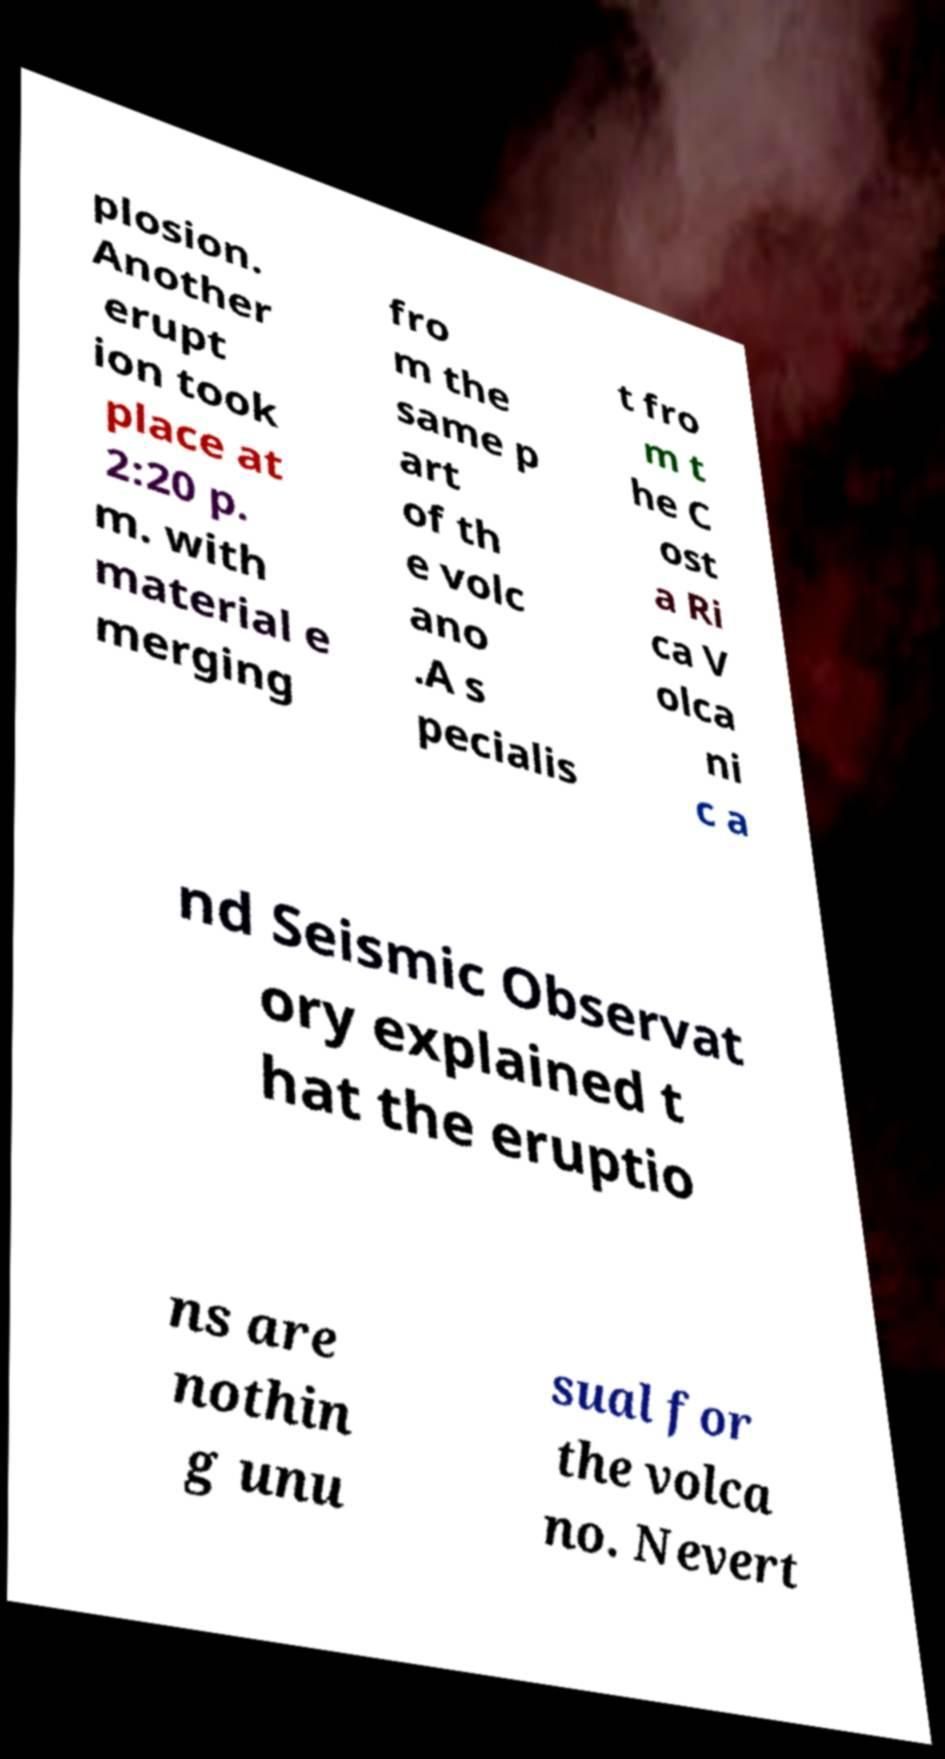Could you extract and type out the text from this image? plosion. Another erupt ion took place at 2:20 p. m. with material e merging fro m the same p art of th e volc ano .A s pecialis t fro m t he C ost a Ri ca V olca ni c a nd Seismic Observat ory explained t hat the eruptio ns are nothin g unu sual for the volca no. Nevert 